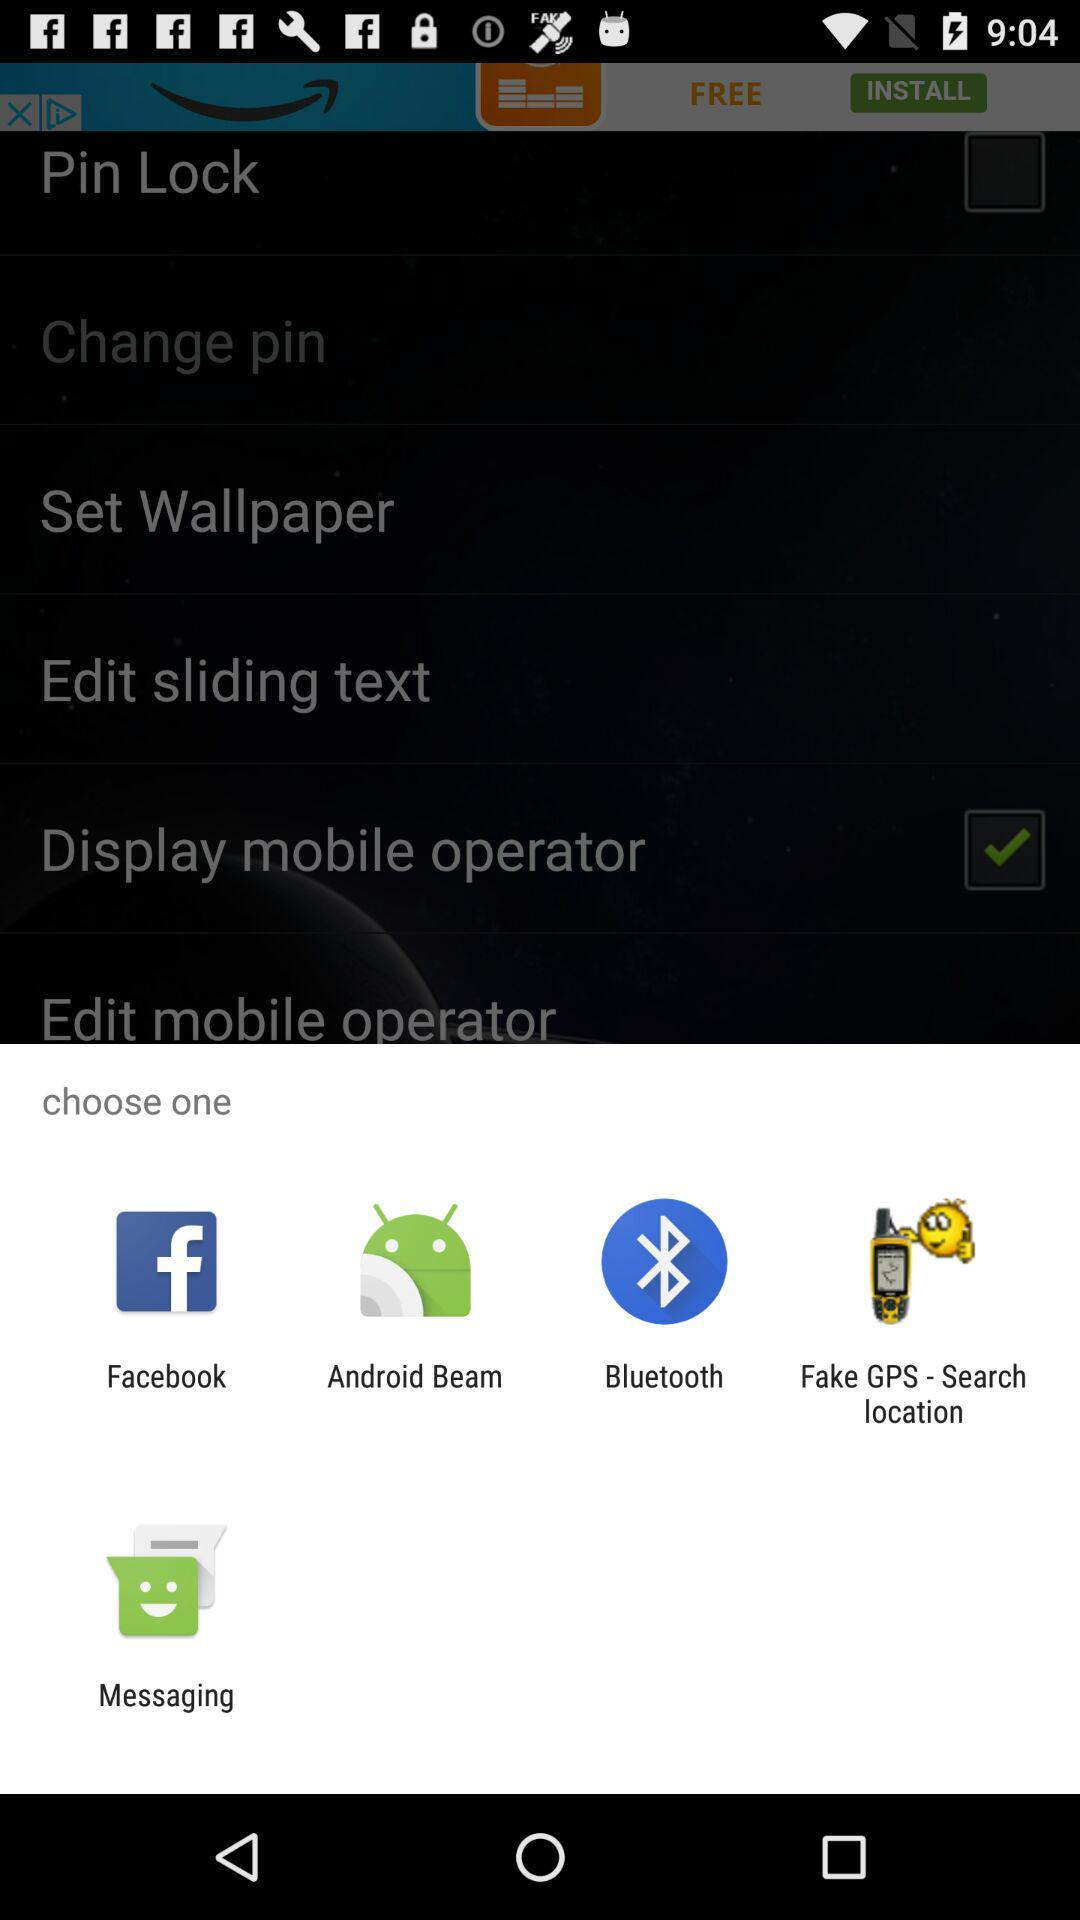What are the apps that can be used to share content? The apps that can be used to share content are "Facebook", "Android Beam", "Bluetooth", "Fake GPS - Search location" and "Messaging". 